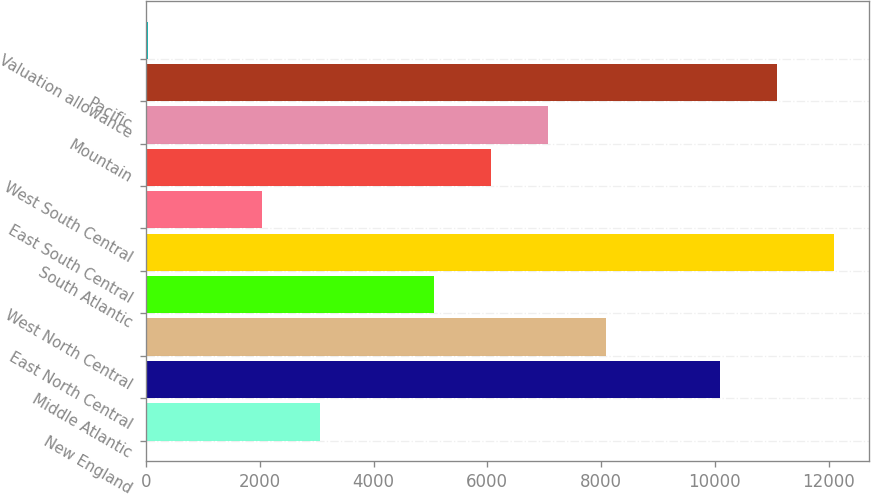Convert chart. <chart><loc_0><loc_0><loc_500><loc_500><bar_chart><fcel>New England<fcel>Middle Atlantic<fcel>East North Central<fcel>West North Central<fcel>South Atlantic<fcel>East South Central<fcel>West South Central<fcel>Mountain<fcel>Pacific<fcel>Valuation allowance<nl><fcel>3049.63<fcel>10090.3<fcel>8078.68<fcel>5061.25<fcel>12101.9<fcel>2043.82<fcel>6067.06<fcel>7072.87<fcel>11096.1<fcel>32.2<nl></chart> 